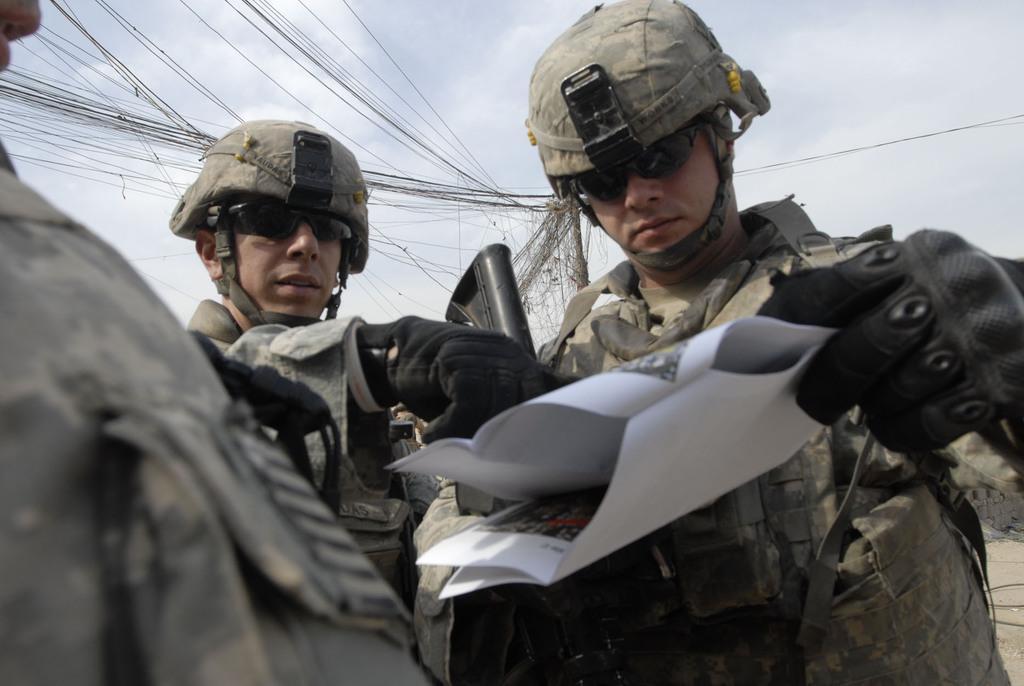How would you summarize this image in a sentence or two? In the center of the image we can see persons holding guns and paper. In the background we can see pole, wires, sky and clouds. 